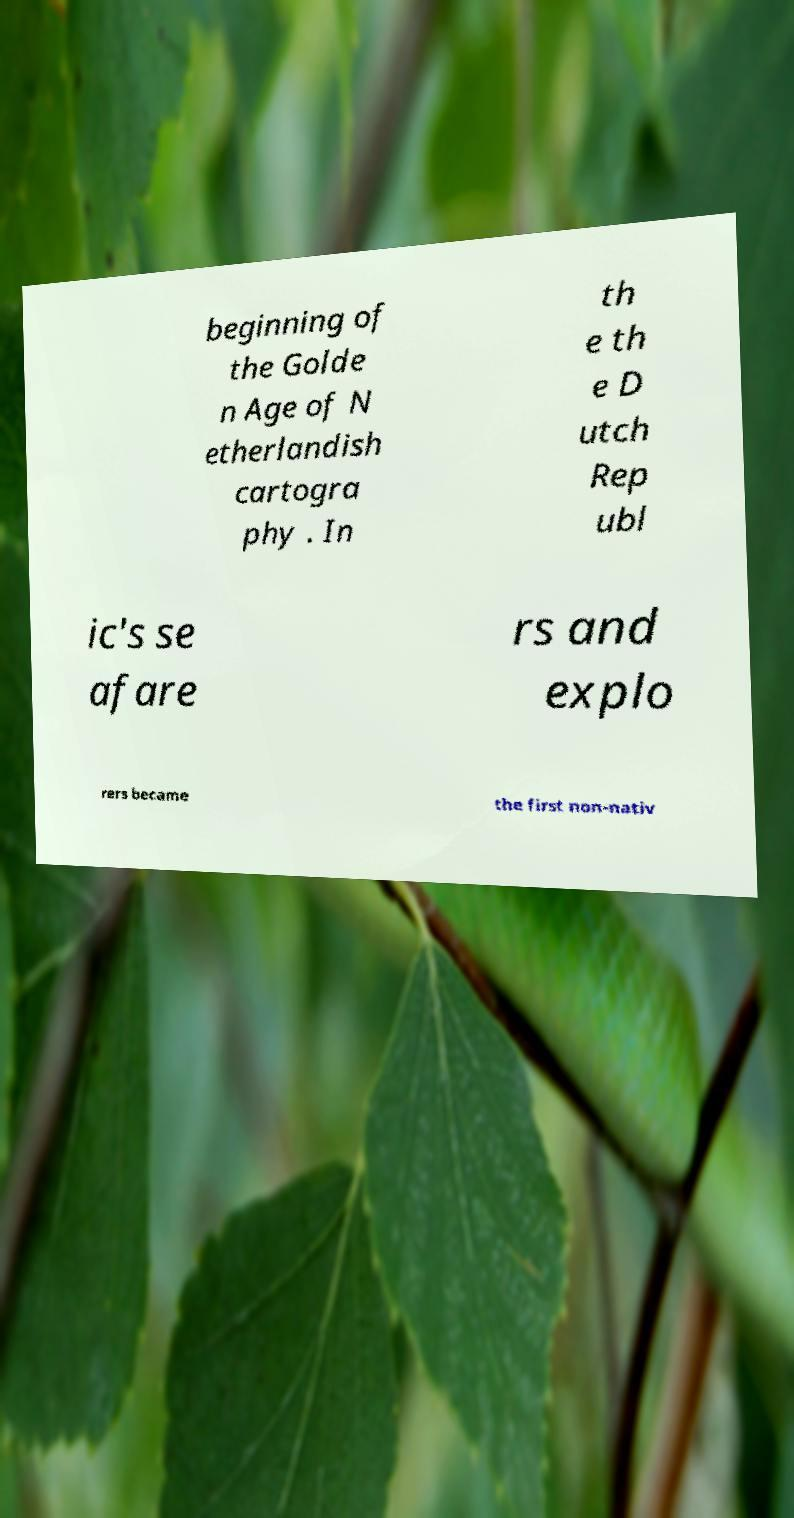I need the written content from this picture converted into text. Can you do that? beginning of the Golde n Age of N etherlandish cartogra phy . In th e th e D utch Rep ubl ic's se afare rs and explo rers became the first non-nativ 